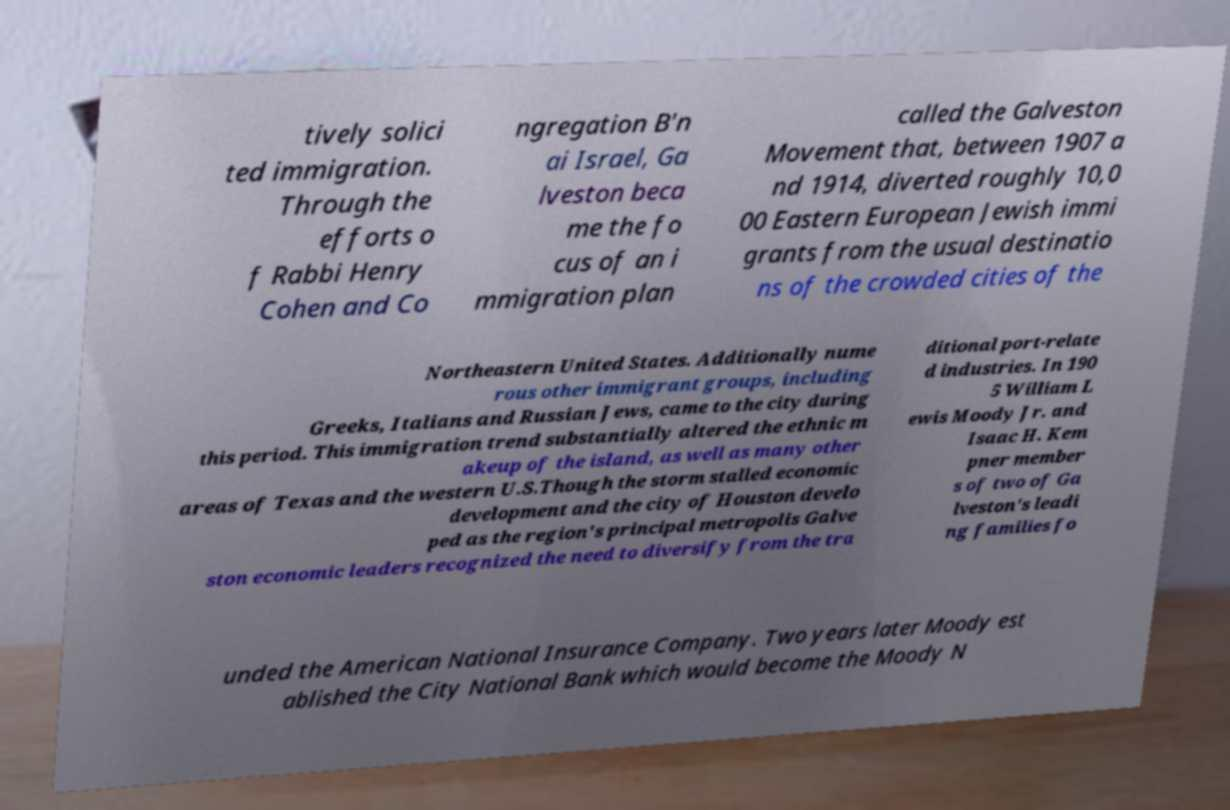There's text embedded in this image that I need extracted. Can you transcribe it verbatim? tively solici ted immigration. Through the efforts o f Rabbi Henry Cohen and Co ngregation B'n ai Israel, Ga lveston beca me the fo cus of an i mmigration plan called the Galveston Movement that, between 1907 a nd 1914, diverted roughly 10,0 00 Eastern European Jewish immi grants from the usual destinatio ns of the crowded cities of the Northeastern United States. Additionally nume rous other immigrant groups, including Greeks, Italians and Russian Jews, came to the city during this period. This immigration trend substantially altered the ethnic m akeup of the island, as well as many other areas of Texas and the western U.S.Though the storm stalled economic development and the city of Houston develo ped as the region's principal metropolis Galve ston economic leaders recognized the need to diversify from the tra ditional port-relate d industries. In 190 5 William L ewis Moody Jr. and Isaac H. Kem pner member s of two of Ga lveston's leadi ng families fo unded the American National Insurance Company. Two years later Moody est ablished the City National Bank which would become the Moody N 